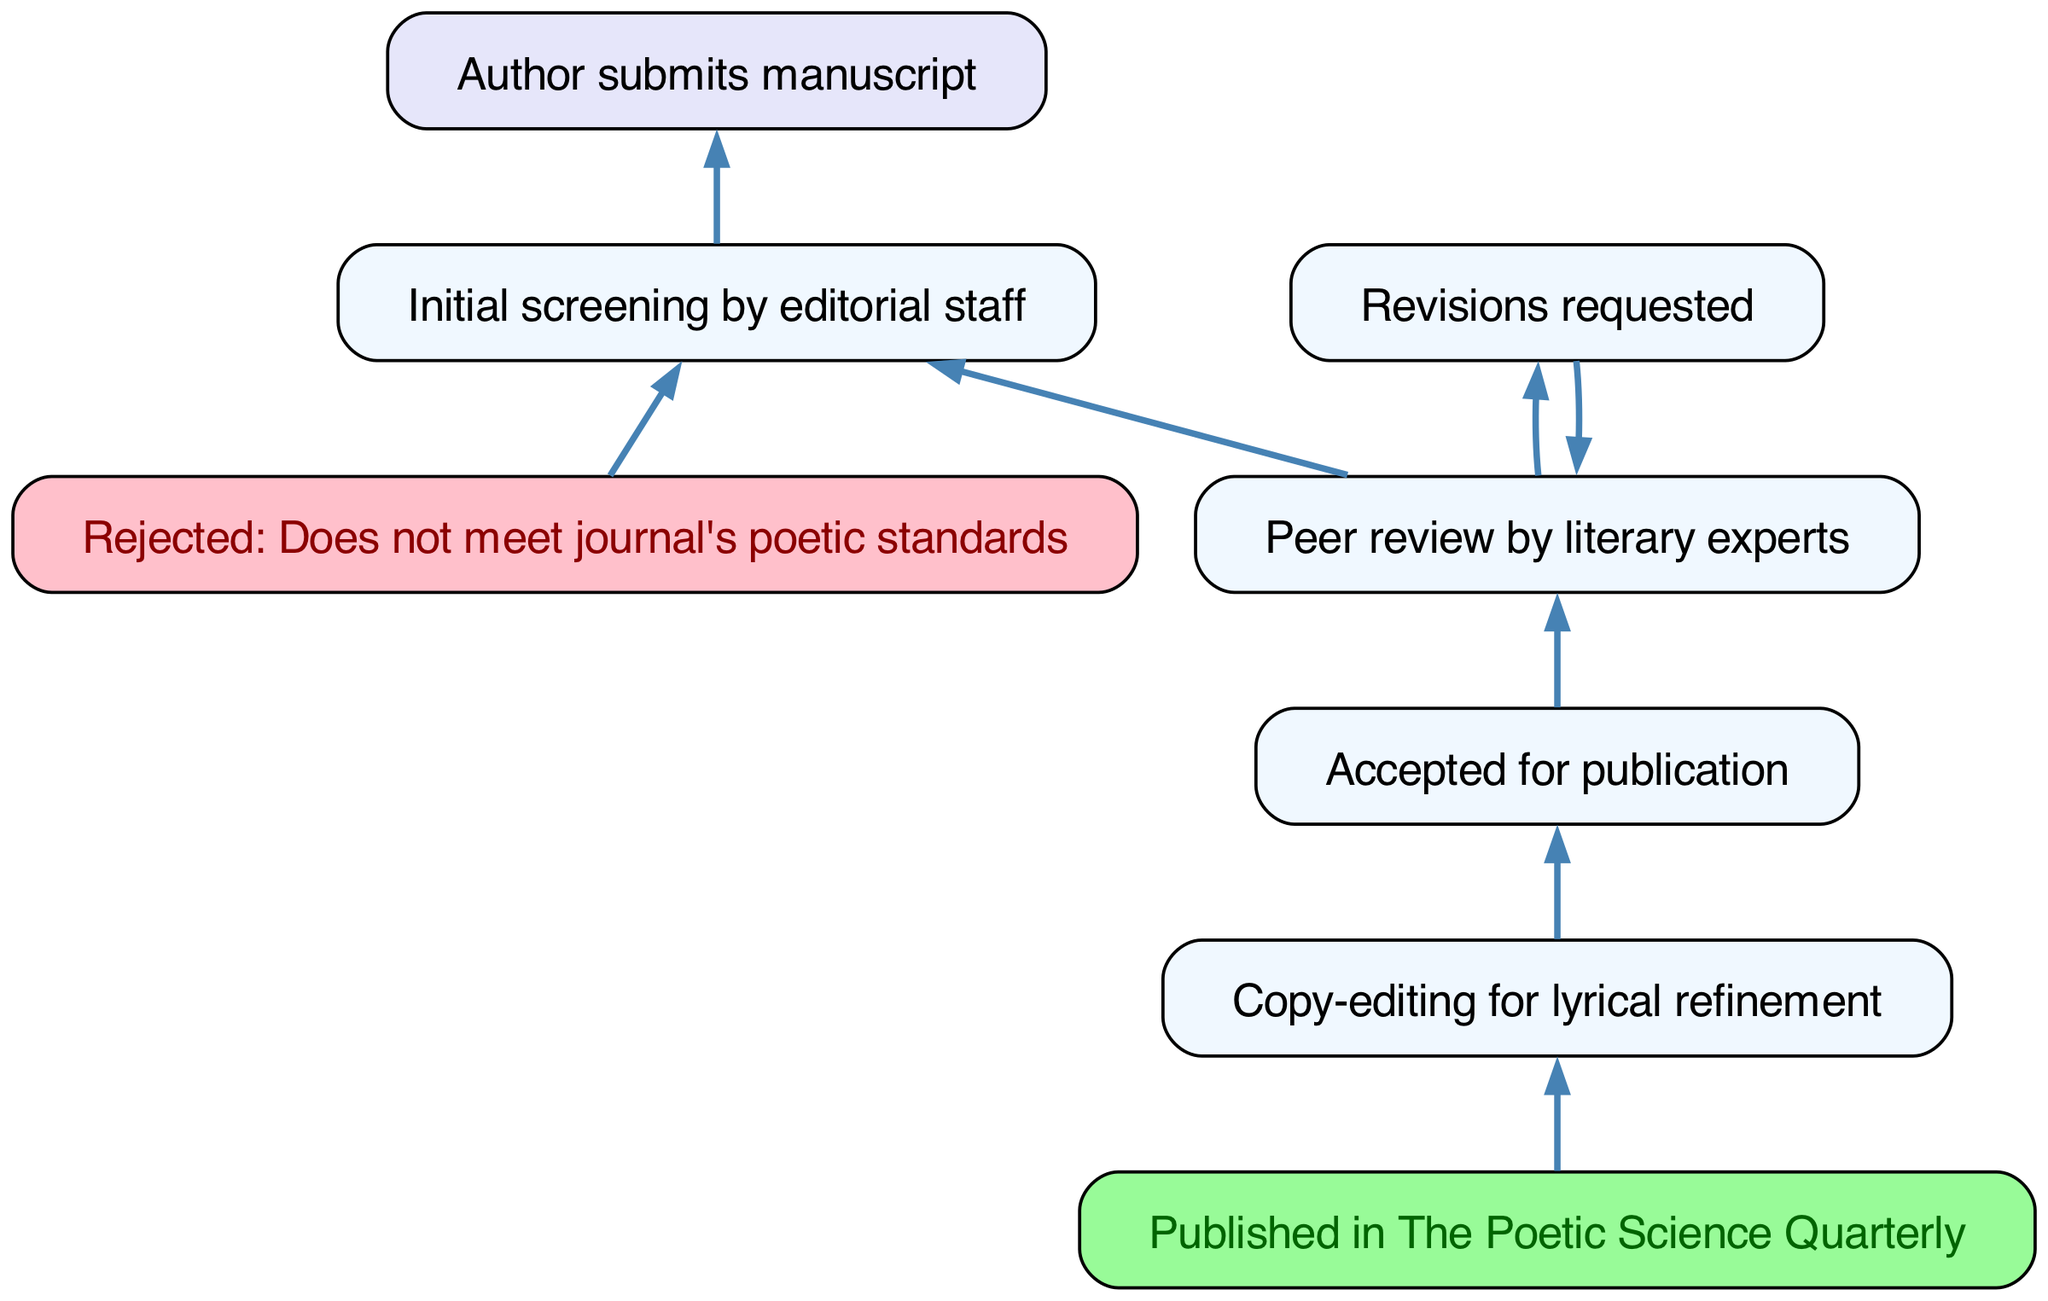What is the first step in the manuscript journey? The diagram indicates that the first step is the manuscript submission by the author, represented by the node "Author submits manuscript."
Answer: Author submits manuscript How many nodes are there in the diagram? Counting each distinct step in the flow chart reveals a total of eight nodes, which represent the various stages from submission to publication.
Answer: Eight What happens after the initial screening by the editorial staff? The options after the initial screening are either a rejection if it does not meet poetic standards or proceeding to peer review by literary experts, as indicated by the connections from the node "Initial screening by editorial staff.”
Answer: Rejected or Peer review by literary experts If the manuscript is accepted for publication, what is the next step? Once the manuscript is accepted for publication, the next step is copy-editing for lyrical refinement, as indicated by the connection from the "Accepted for publication" node to the "Copy-editing for lyrical refinement" node.
Answer: Copy-editing for lyrical refinement What can occur after peer review by literary experts? After peer review, there are two outcomes: revisions may be requested, leading back to peer review, or the manuscript may be accepted for publication, which means the manuscript can reach the next stage of the process.
Answer: Revisions requested or Accepted for publication What color represents rejected nodes in the diagram? The diagram uses a distinct color, specifically pink, to signify nodes associated with rejection, making them easily identifiable among other nodes.
Answer: Pink What is the final outcome in the manuscript journey? The diagram indicates that the final outcome after all previous steps is the publication in "The Poetic Science Quarterly," as shown by the last node in the sequence.
Answer: Published in The Poetic Science Quarterly How many edges connect to the "Initial screening by editorial staff" node? The "Initial screening by editorial staff" node connects to two other nodes: one leading to rejection and another leading to peer review, indicating the decision-making process following the screening.
Answer: Two 